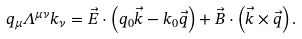<formula> <loc_0><loc_0><loc_500><loc_500>q _ { \mu } \Lambda ^ { \mu \nu } k _ { \nu } = \vec { E } \cdot \left ( q _ { 0 } \vec { k } - k _ { 0 } \vec { q } \right ) + \vec { B } \cdot \left ( \vec { k } \times \vec { q } \right ) .</formula> 